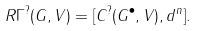<formula> <loc_0><loc_0><loc_500><loc_500>R \Gamma ^ { ? } ( G , V ) = [ C ^ { ? } ( G ^ { \bullet } , V ) , d ^ { n } ] .</formula> 